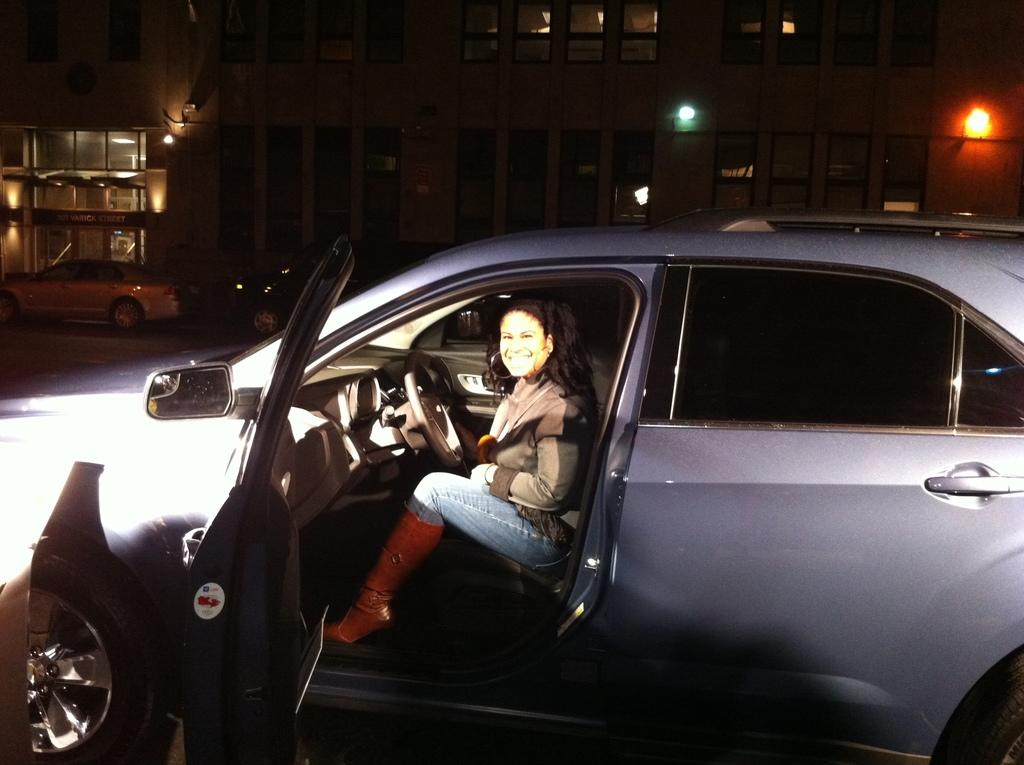Where was the image taken? The image was taken on a road. What type of vehicle is in the image? There is a blue car in the image. Who is inside the car? A woman is sitting in the car. What can be seen in the distance behind the car? There are buildings and other cars in the background. What type of can is visible in the image? There is no can present in the image. What prose is being recited by the woman in the car? The image does not show or suggest that the woman is reciting any prose. 